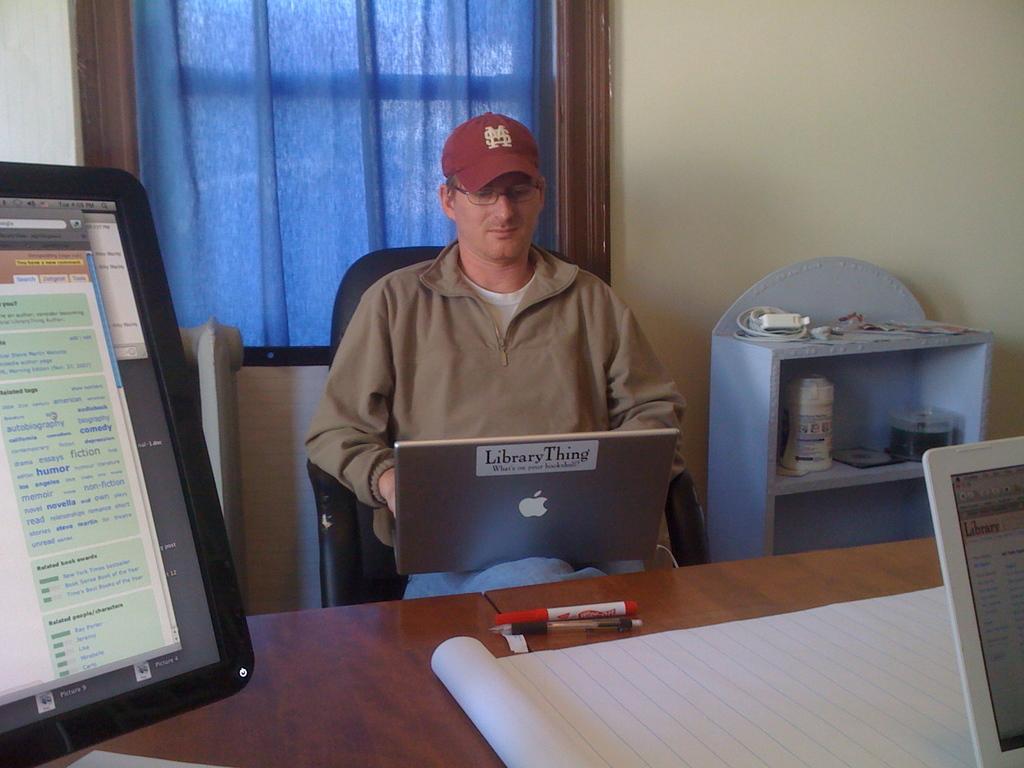What does the sticker say on the back of his laptop?
Provide a short and direct response. Library thing. What letter is on the mans red hat?
Make the answer very short. Ms. 